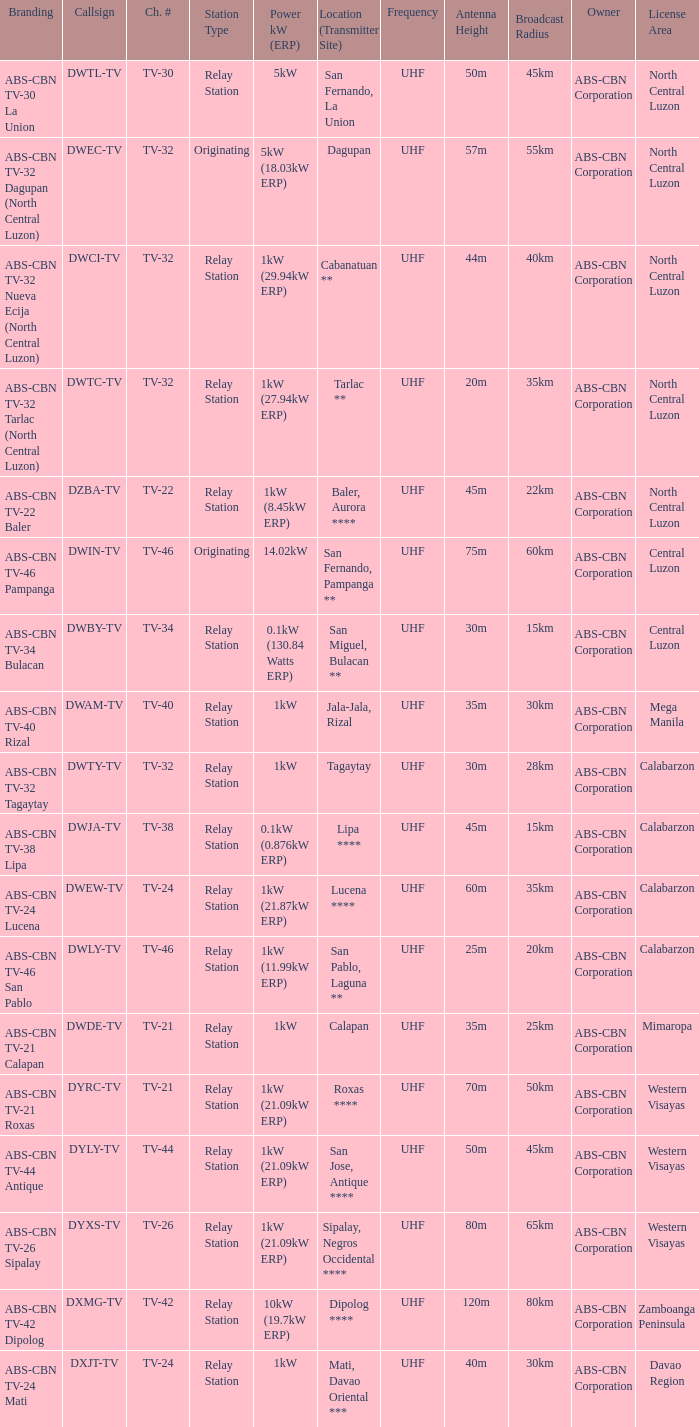How many brandings are there where the Power kW (ERP) is 1kW (29.94kW ERP)? 1.0. 